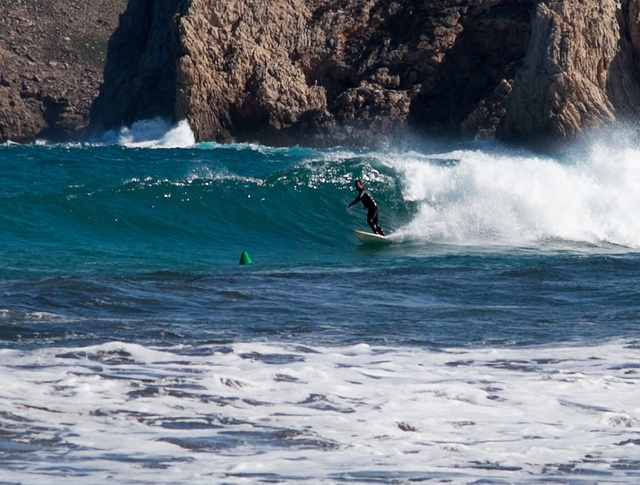Describe the objects in this image and their specific colors. I can see people in gray, black, purple, and darkgray tones and surfboard in gray, black, darkgray, and teal tones in this image. 